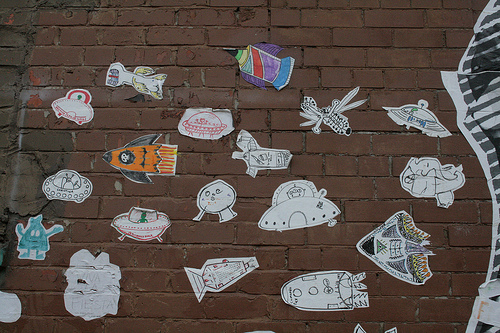<image>
Is the apple in front of the orange? No. The apple is not in front of the orange. The spatial positioning shows a different relationship between these objects. 